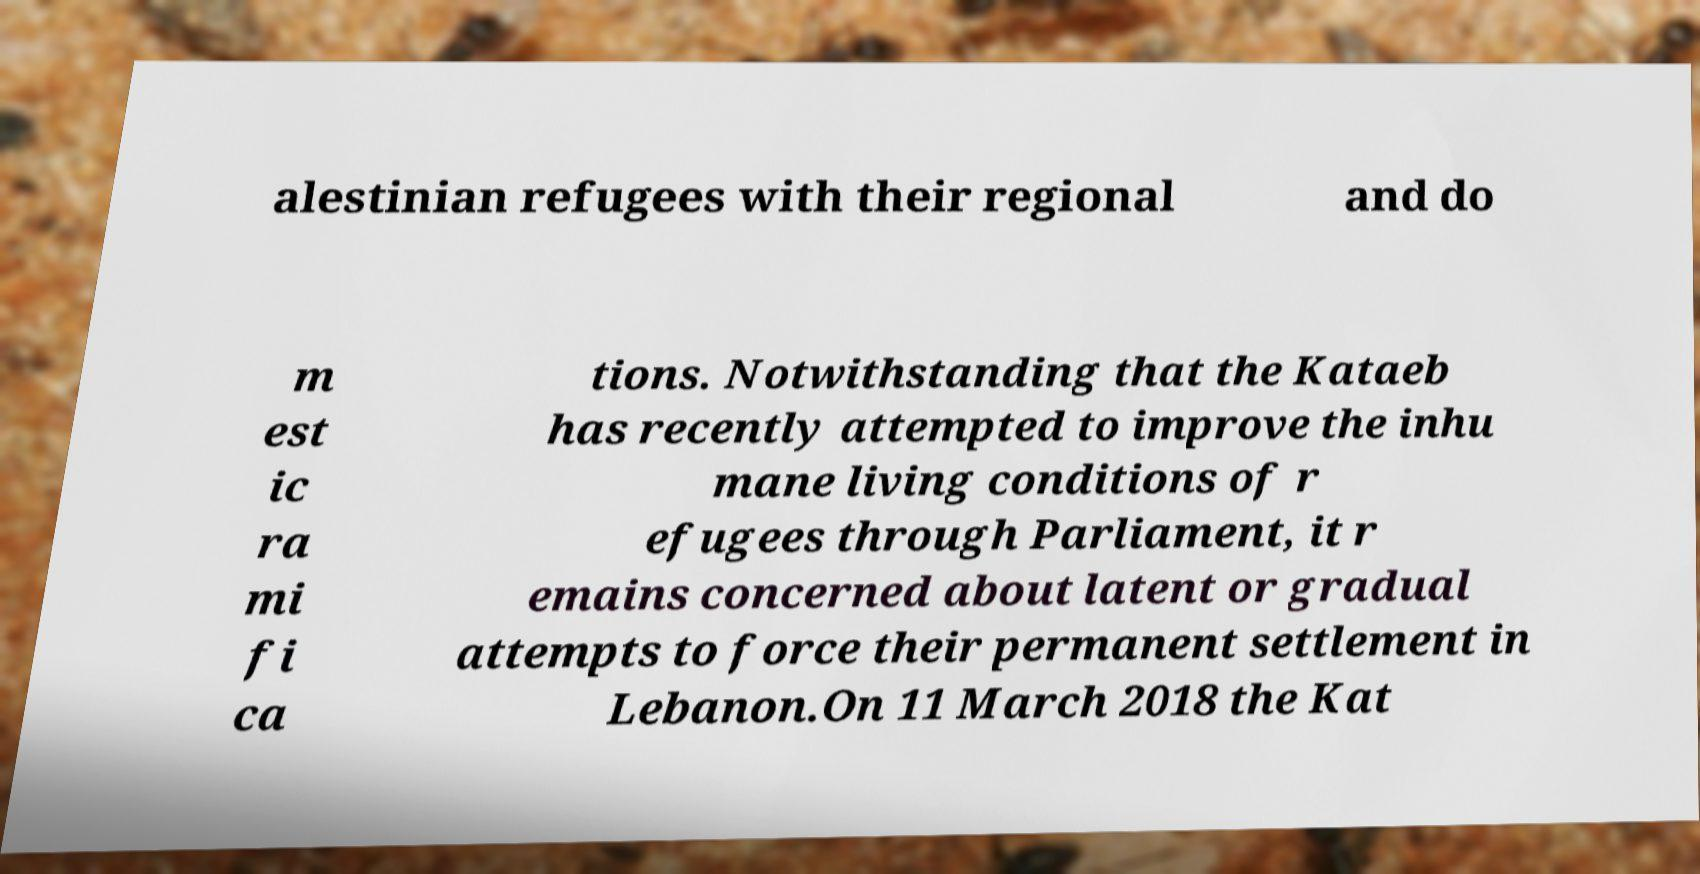For documentation purposes, I need the text within this image transcribed. Could you provide that? alestinian refugees with their regional and do m est ic ra mi fi ca tions. Notwithstanding that the Kataeb has recently attempted to improve the inhu mane living conditions of r efugees through Parliament, it r emains concerned about latent or gradual attempts to force their permanent settlement in Lebanon.On 11 March 2018 the Kat 